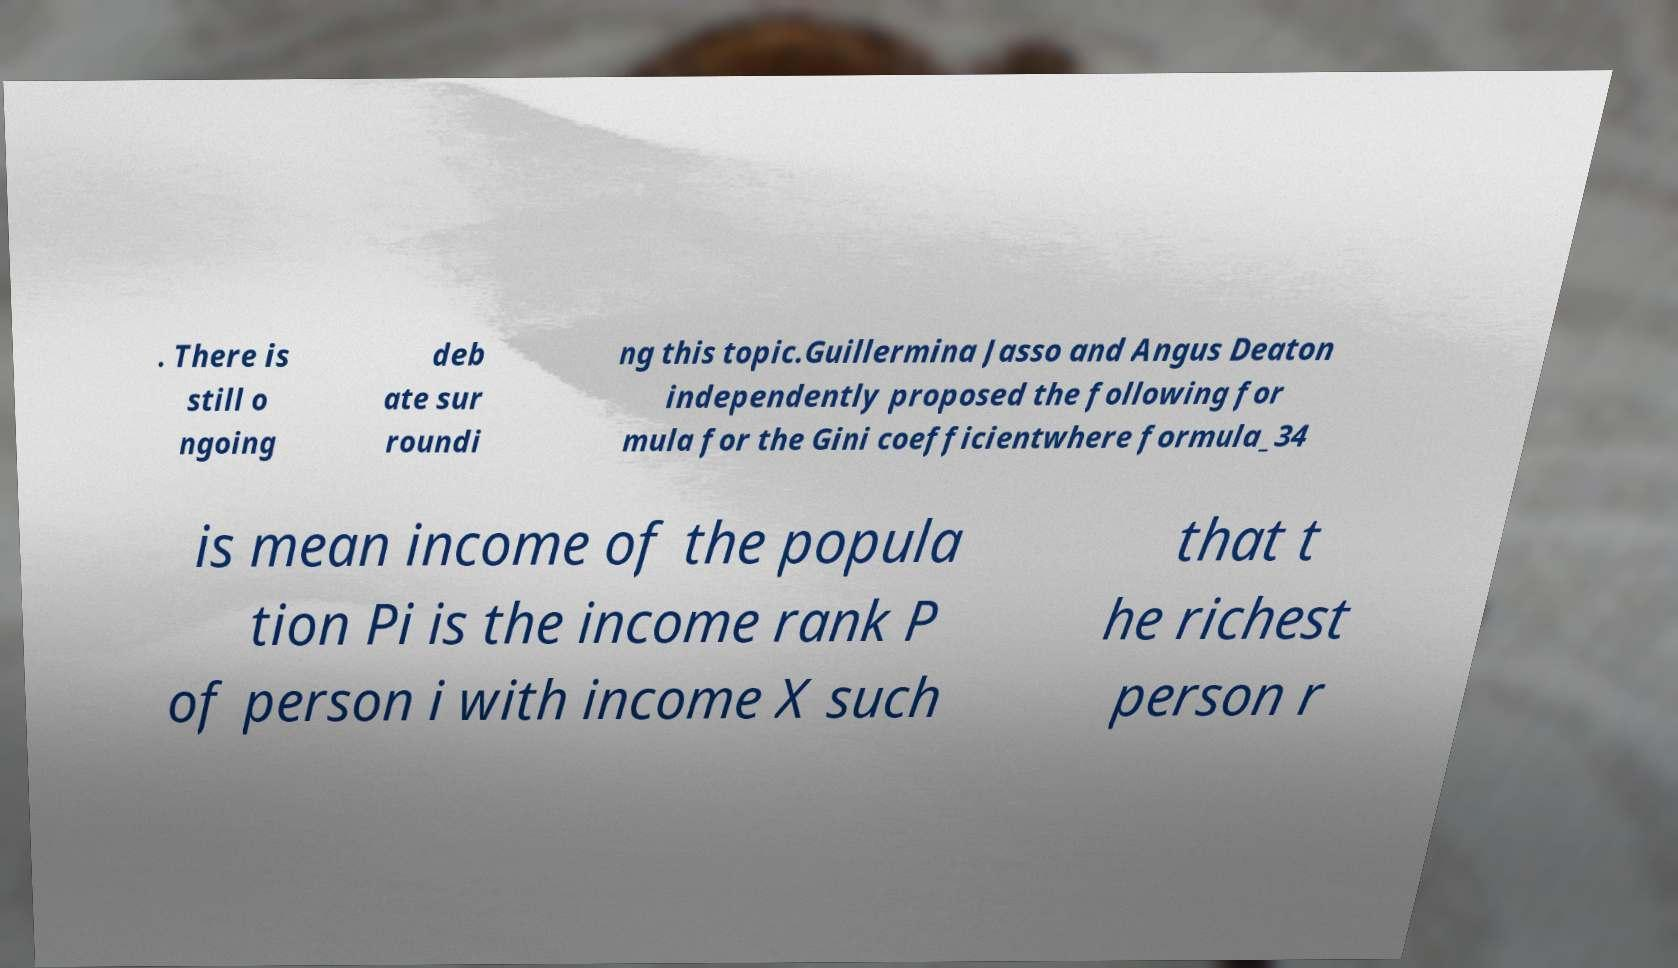Can you accurately transcribe the text from the provided image for me? . There is still o ngoing deb ate sur roundi ng this topic.Guillermina Jasso and Angus Deaton independently proposed the following for mula for the Gini coefficientwhere formula_34 is mean income of the popula tion Pi is the income rank P of person i with income X such that t he richest person r 